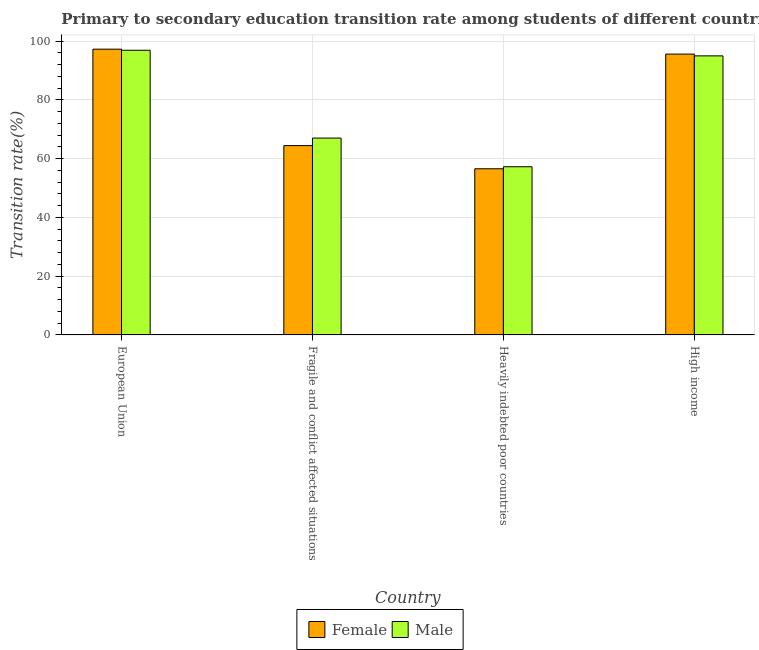How many different coloured bars are there?
Keep it short and to the point. 2. What is the label of the 1st group of bars from the left?
Your response must be concise. European Union. In how many cases, is the number of bars for a given country not equal to the number of legend labels?
Offer a very short reply. 0. What is the transition rate among male students in High income?
Keep it short and to the point. 94.96. Across all countries, what is the maximum transition rate among male students?
Keep it short and to the point. 96.87. Across all countries, what is the minimum transition rate among male students?
Your response must be concise. 57.23. In which country was the transition rate among female students minimum?
Provide a succinct answer. Heavily indebted poor countries. What is the total transition rate among male students in the graph?
Offer a terse response. 316.05. What is the difference between the transition rate among male students in Fragile and conflict affected situations and that in High income?
Your response must be concise. -27.97. What is the difference between the transition rate among male students in European Union and the transition rate among female students in Heavily indebted poor countries?
Offer a terse response. 40.33. What is the average transition rate among female students per country?
Offer a terse response. 78.44. What is the difference between the transition rate among female students and transition rate among male students in Fragile and conflict affected situations?
Provide a succinct answer. -2.57. In how many countries, is the transition rate among female students greater than 36 %?
Provide a short and direct response. 4. What is the ratio of the transition rate among female students in Heavily indebted poor countries to that in High income?
Give a very brief answer. 0.59. Is the difference between the transition rate among female students in Fragile and conflict affected situations and Heavily indebted poor countries greater than the difference between the transition rate among male students in Fragile and conflict affected situations and Heavily indebted poor countries?
Provide a short and direct response. No. What is the difference between the highest and the second highest transition rate among female students?
Provide a short and direct response. 1.68. What is the difference between the highest and the lowest transition rate among male students?
Provide a short and direct response. 39.64. In how many countries, is the transition rate among male students greater than the average transition rate among male students taken over all countries?
Provide a short and direct response. 2. What does the 1st bar from the left in Fragile and conflict affected situations represents?
Provide a succinct answer. Female. How many countries are there in the graph?
Offer a terse response. 4. What is the difference between two consecutive major ticks on the Y-axis?
Your response must be concise. 20. Are the values on the major ticks of Y-axis written in scientific E-notation?
Provide a succinct answer. No. Does the graph contain any zero values?
Your answer should be compact. No. Does the graph contain grids?
Offer a terse response. Yes. How many legend labels are there?
Your response must be concise. 2. How are the legend labels stacked?
Offer a terse response. Horizontal. What is the title of the graph?
Ensure brevity in your answer.  Primary to secondary education transition rate among students of different countries. What is the label or title of the X-axis?
Offer a very short reply. Country. What is the label or title of the Y-axis?
Your answer should be very brief. Transition rate(%). What is the Transition rate(%) of Female in European Union?
Offer a very short reply. 97.24. What is the Transition rate(%) in Male in European Union?
Ensure brevity in your answer.  96.87. What is the Transition rate(%) of Female in Fragile and conflict affected situations?
Keep it short and to the point. 64.42. What is the Transition rate(%) in Male in Fragile and conflict affected situations?
Ensure brevity in your answer.  66.99. What is the Transition rate(%) in Female in Heavily indebted poor countries?
Keep it short and to the point. 56.54. What is the Transition rate(%) of Male in Heavily indebted poor countries?
Provide a succinct answer. 57.23. What is the Transition rate(%) of Female in High income?
Offer a terse response. 95.56. What is the Transition rate(%) of Male in High income?
Keep it short and to the point. 94.96. Across all countries, what is the maximum Transition rate(%) in Female?
Provide a short and direct response. 97.24. Across all countries, what is the maximum Transition rate(%) in Male?
Ensure brevity in your answer.  96.87. Across all countries, what is the minimum Transition rate(%) in Female?
Provide a short and direct response. 56.54. Across all countries, what is the minimum Transition rate(%) in Male?
Provide a succinct answer. 57.23. What is the total Transition rate(%) in Female in the graph?
Your response must be concise. 313.76. What is the total Transition rate(%) in Male in the graph?
Offer a terse response. 316.05. What is the difference between the Transition rate(%) in Female in European Union and that in Fragile and conflict affected situations?
Your response must be concise. 32.82. What is the difference between the Transition rate(%) of Male in European Union and that in Fragile and conflict affected situations?
Offer a terse response. 29.88. What is the difference between the Transition rate(%) in Female in European Union and that in Heavily indebted poor countries?
Provide a short and direct response. 40.71. What is the difference between the Transition rate(%) in Male in European Union and that in Heavily indebted poor countries?
Make the answer very short. 39.64. What is the difference between the Transition rate(%) of Female in European Union and that in High income?
Your answer should be very brief. 1.68. What is the difference between the Transition rate(%) in Male in European Union and that in High income?
Provide a short and direct response. 1.91. What is the difference between the Transition rate(%) of Female in Fragile and conflict affected situations and that in Heavily indebted poor countries?
Provide a succinct answer. 7.89. What is the difference between the Transition rate(%) in Male in Fragile and conflict affected situations and that in Heavily indebted poor countries?
Provide a succinct answer. 9.76. What is the difference between the Transition rate(%) of Female in Fragile and conflict affected situations and that in High income?
Give a very brief answer. -31.14. What is the difference between the Transition rate(%) in Male in Fragile and conflict affected situations and that in High income?
Offer a very short reply. -27.97. What is the difference between the Transition rate(%) of Female in Heavily indebted poor countries and that in High income?
Provide a short and direct response. -39.03. What is the difference between the Transition rate(%) of Male in Heavily indebted poor countries and that in High income?
Your answer should be very brief. -37.73. What is the difference between the Transition rate(%) of Female in European Union and the Transition rate(%) of Male in Fragile and conflict affected situations?
Your answer should be compact. 30.25. What is the difference between the Transition rate(%) in Female in European Union and the Transition rate(%) in Male in Heavily indebted poor countries?
Give a very brief answer. 40.01. What is the difference between the Transition rate(%) in Female in European Union and the Transition rate(%) in Male in High income?
Give a very brief answer. 2.28. What is the difference between the Transition rate(%) of Female in Fragile and conflict affected situations and the Transition rate(%) of Male in Heavily indebted poor countries?
Your answer should be very brief. 7.19. What is the difference between the Transition rate(%) in Female in Fragile and conflict affected situations and the Transition rate(%) in Male in High income?
Provide a short and direct response. -30.54. What is the difference between the Transition rate(%) of Female in Heavily indebted poor countries and the Transition rate(%) of Male in High income?
Offer a terse response. -38.43. What is the average Transition rate(%) of Female per country?
Provide a short and direct response. 78.44. What is the average Transition rate(%) of Male per country?
Ensure brevity in your answer.  79.01. What is the difference between the Transition rate(%) in Female and Transition rate(%) in Male in European Union?
Your answer should be compact. 0.38. What is the difference between the Transition rate(%) of Female and Transition rate(%) of Male in Fragile and conflict affected situations?
Give a very brief answer. -2.57. What is the difference between the Transition rate(%) in Female and Transition rate(%) in Male in Heavily indebted poor countries?
Make the answer very short. -0.69. What is the difference between the Transition rate(%) in Female and Transition rate(%) in Male in High income?
Your answer should be very brief. 0.6. What is the ratio of the Transition rate(%) in Female in European Union to that in Fragile and conflict affected situations?
Give a very brief answer. 1.51. What is the ratio of the Transition rate(%) in Male in European Union to that in Fragile and conflict affected situations?
Your response must be concise. 1.45. What is the ratio of the Transition rate(%) of Female in European Union to that in Heavily indebted poor countries?
Your answer should be very brief. 1.72. What is the ratio of the Transition rate(%) of Male in European Union to that in Heavily indebted poor countries?
Make the answer very short. 1.69. What is the ratio of the Transition rate(%) of Female in European Union to that in High income?
Your answer should be compact. 1.02. What is the ratio of the Transition rate(%) of Male in European Union to that in High income?
Provide a short and direct response. 1.02. What is the ratio of the Transition rate(%) of Female in Fragile and conflict affected situations to that in Heavily indebted poor countries?
Your answer should be compact. 1.14. What is the ratio of the Transition rate(%) of Male in Fragile and conflict affected situations to that in Heavily indebted poor countries?
Keep it short and to the point. 1.17. What is the ratio of the Transition rate(%) in Female in Fragile and conflict affected situations to that in High income?
Make the answer very short. 0.67. What is the ratio of the Transition rate(%) of Male in Fragile and conflict affected situations to that in High income?
Make the answer very short. 0.71. What is the ratio of the Transition rate(%) of Female in Heavily indebted poor countries to that in High income?
Your answer should be very brief. 0.59. What is the ratio of the Transition rate(%) in Male in Heavily indebted poor countries to that in High income?
Give a very brief answer. 0.6. What is the difference between the highest and the second highest Transition rate(%) in Female?
Make the answer very short. 1.68. What is the difference between the highest and the second highest Transition rate(%) in Male?
Offer a terse response. 1.91. What is the difference between the highest and the lowest Transition rate(%) in Female?
Your response must be concise. 40.71. What is the difference between the highest and the lowest Transition rate(%) of Male?
Give a very brief answer. 39.64. 